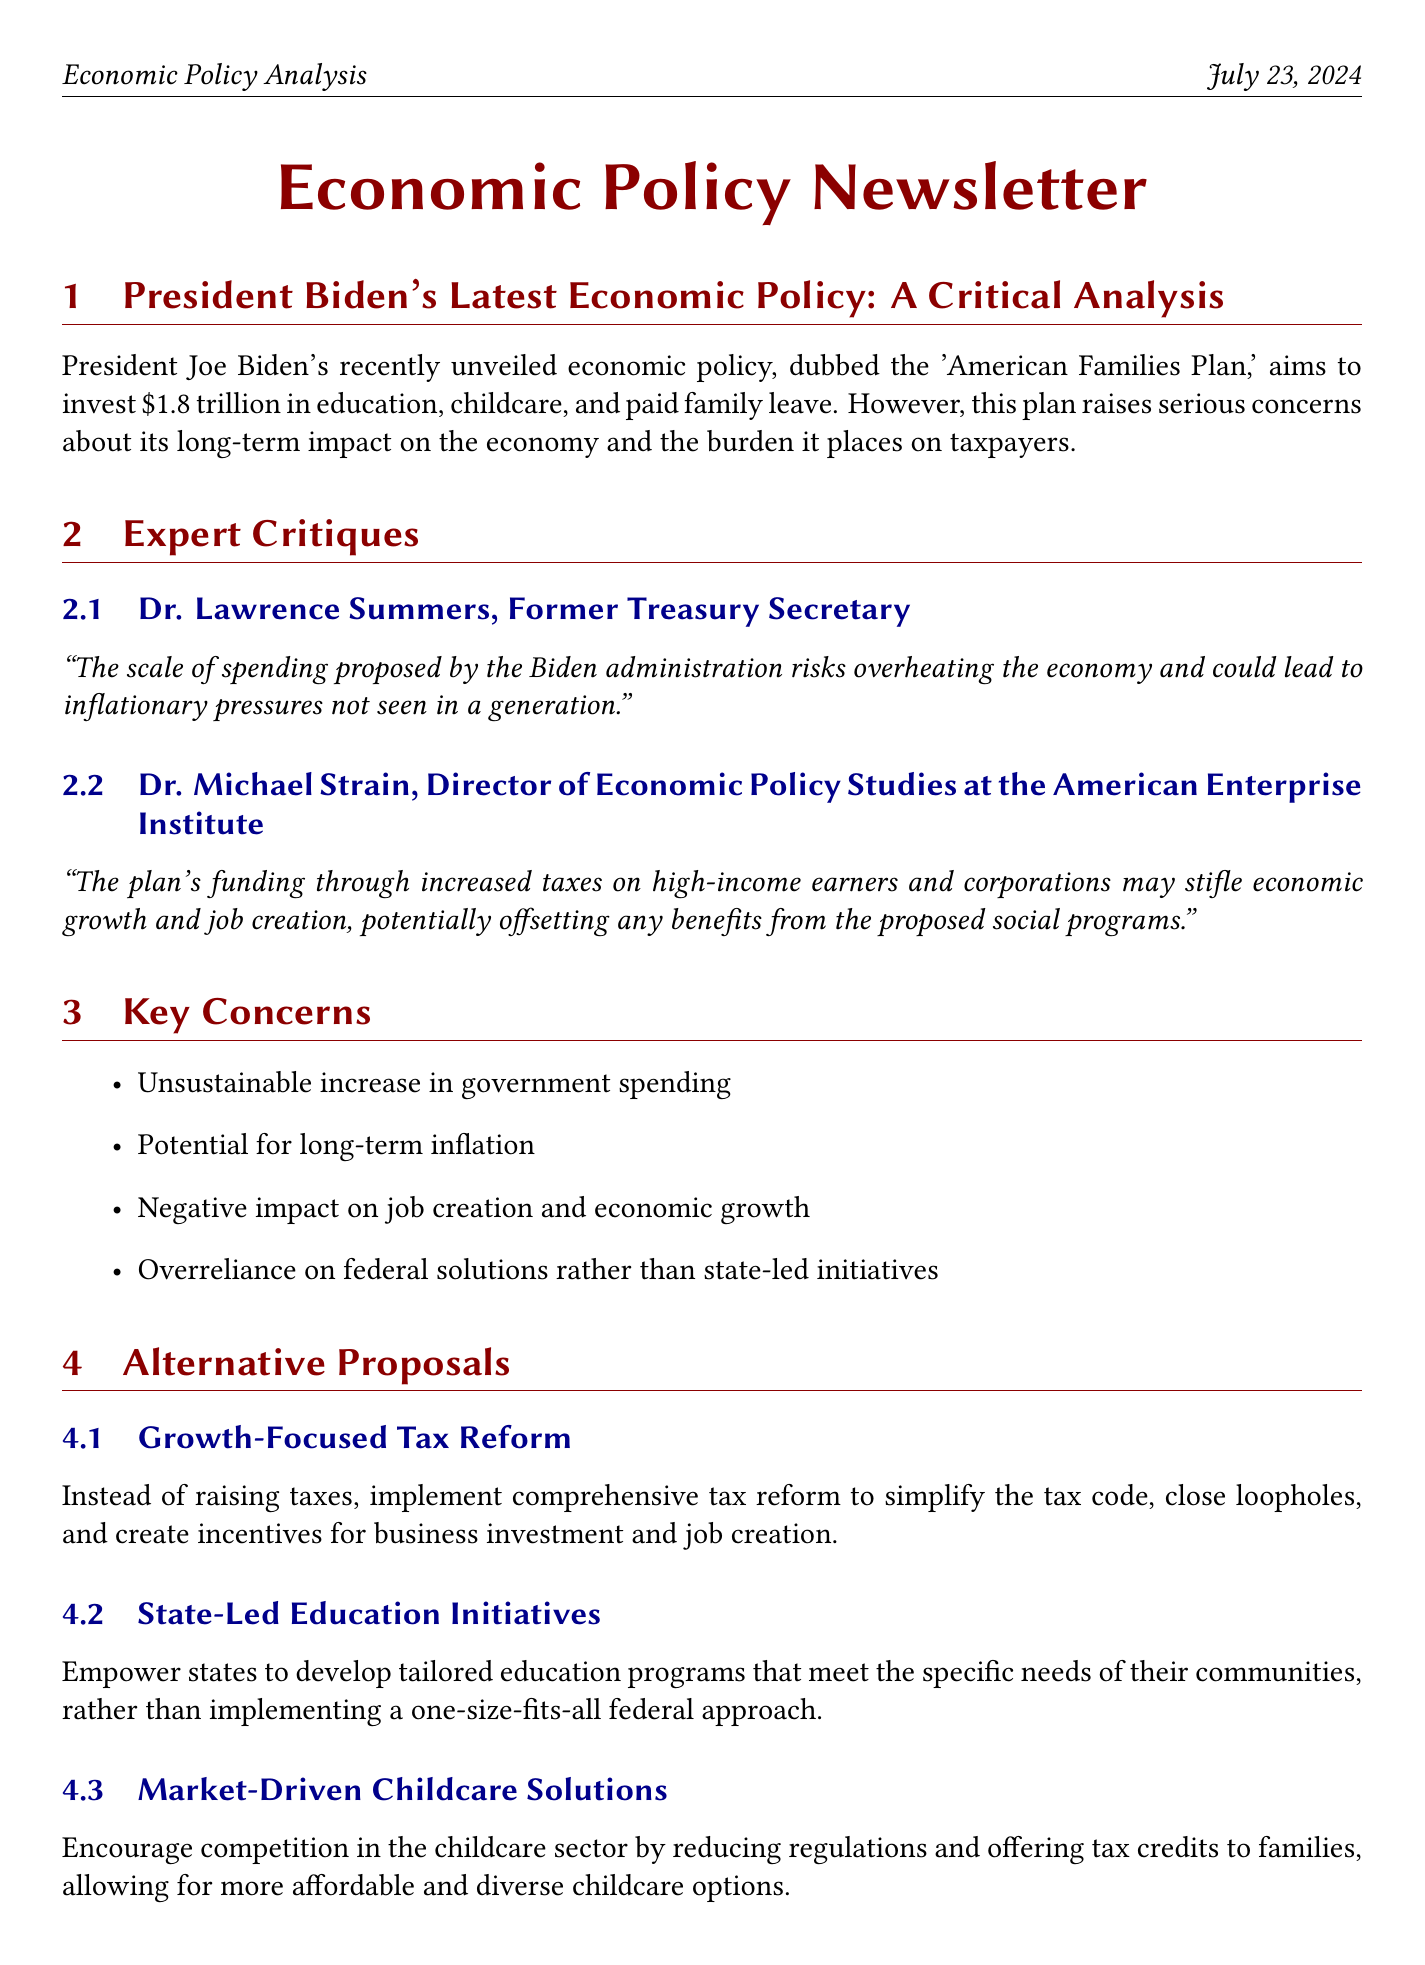What is the name of President Biden's economic policy? The document refers to it as the 'American Families Plan.'
Answer: American Families Plan How much funding is proposed in the 'American Families Plan'? The document states that the plan aims to invest $1.8 trillion.
Answer: $1.8 trillion Who is Dr. Lawrence Summers? He is identified as the Former Treasury Secretary in the document.
Answer: Former Treasury Secretary What is one of the key concerns regarding the Biden plan? The document lists concerns, including the unsustainable increase in government spending.
Answer: Unsustainable increase in government spending According to the Congressional Budget Office, what is the projected reduction in GDP growth? The document mentions a 0.3% reduction in GDP growth over the next decade.
Answer: 0.3% What alternative proposal encourages competition in the childcare sector? The document refers to it as Market-Driven Childcare Solutions.
Answer: Market-Driven Childcare Solutions How many fewer jobs are projected to be created by 2031 as a result of the Biden plan? The document states that approximately 636,000 fewer jobs could be created.
Answer: 636,000 What is a suggested approach to education in the alternative proposals? The document suggests State-Led Education Initiatives.
Answer: State-Led Education Initiatives What are the document's views on the approach of Biden's economic policy? The document concludes that the approach is fundamentally flawed.
Answer: Fundamentally flawed 